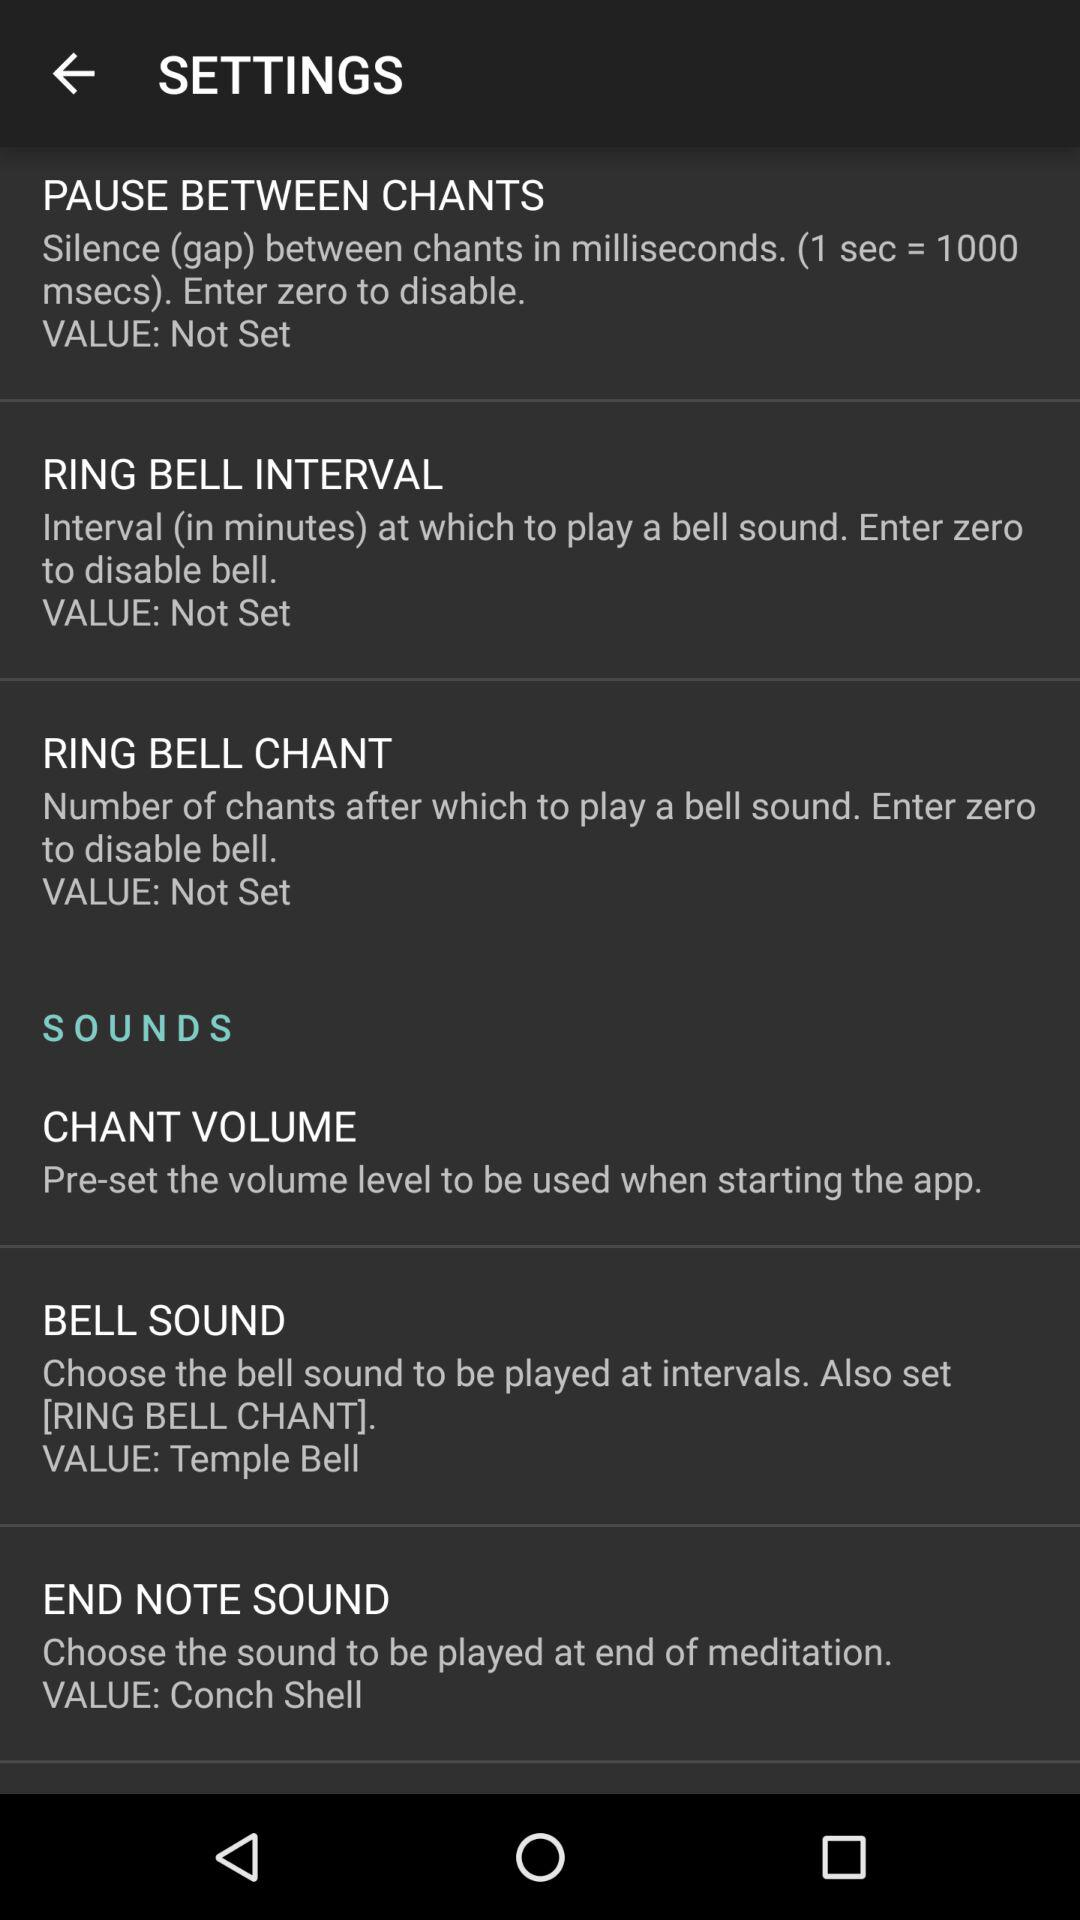What value is entered to disable the bell for "PAUSE BETWEEN CHANTS"? Enter zero to disable the bell for "PAUSE BETWEEN CHANTS". 